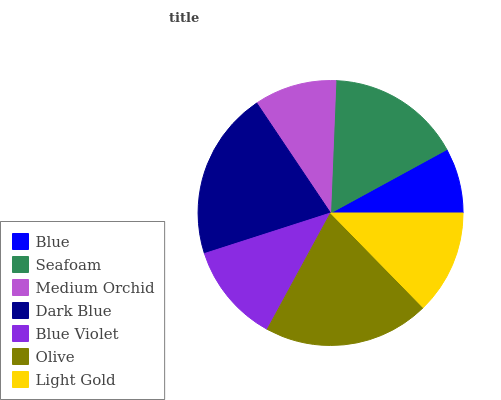Is Blue the minimum?
Answer yes or no. Yes. Is Dark Blue the maximum?
Answer yes or no. Yes. Is Seafoam the minimum?
Answer yes or no. No. Is Seafoam the maximum?
Answer yes or no. No. Is Seafoam greater than Blue?
Answer yes or no. Yes. Is Blue less than Seafoam?
Answer yes or no. Yes. Is Blue greater than Seafoam?
Answer yes or no. No. Is Seafoam less than Blue?
Answer yes or no. No. Is Light Gold the high median?
Answer yes or no. Yes. Is Light Gold the low median?
Answer yes or no. Yes. Is Seafoam the high median?
Answer yes or no. No. Is Medium Orchid the low median?
Answer yes or no. No. 